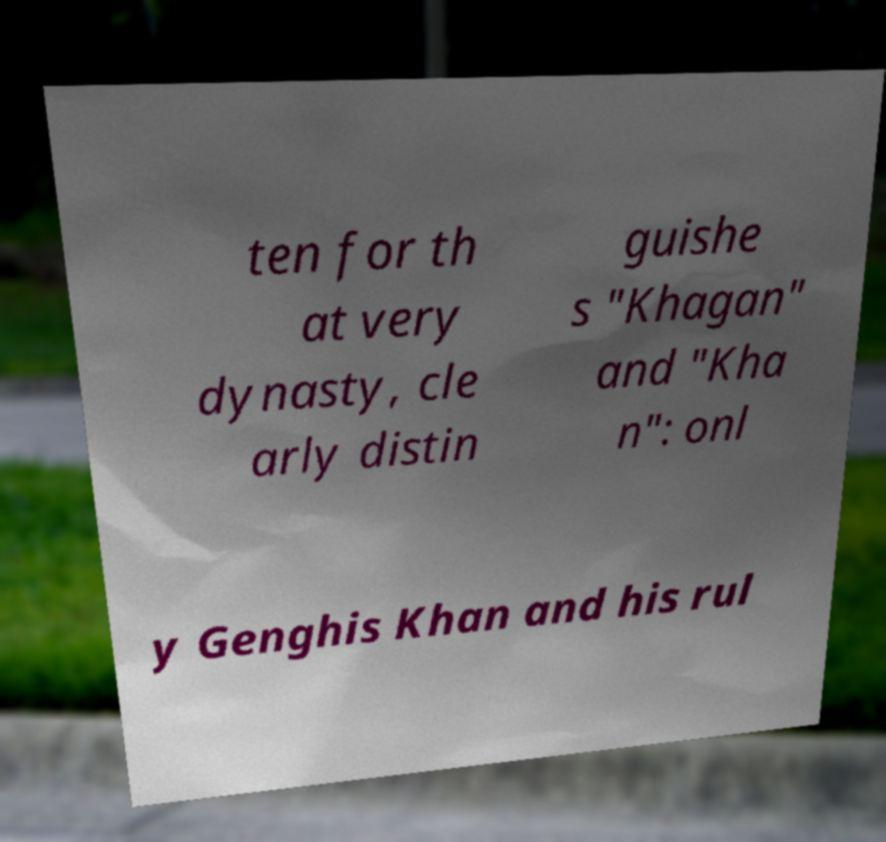Could you extract and type out the text from this image? ten for th at very dynasty, cle arly distin guishe s "Khagan" and "Kha n": onl y Genghis Khan and his rul 